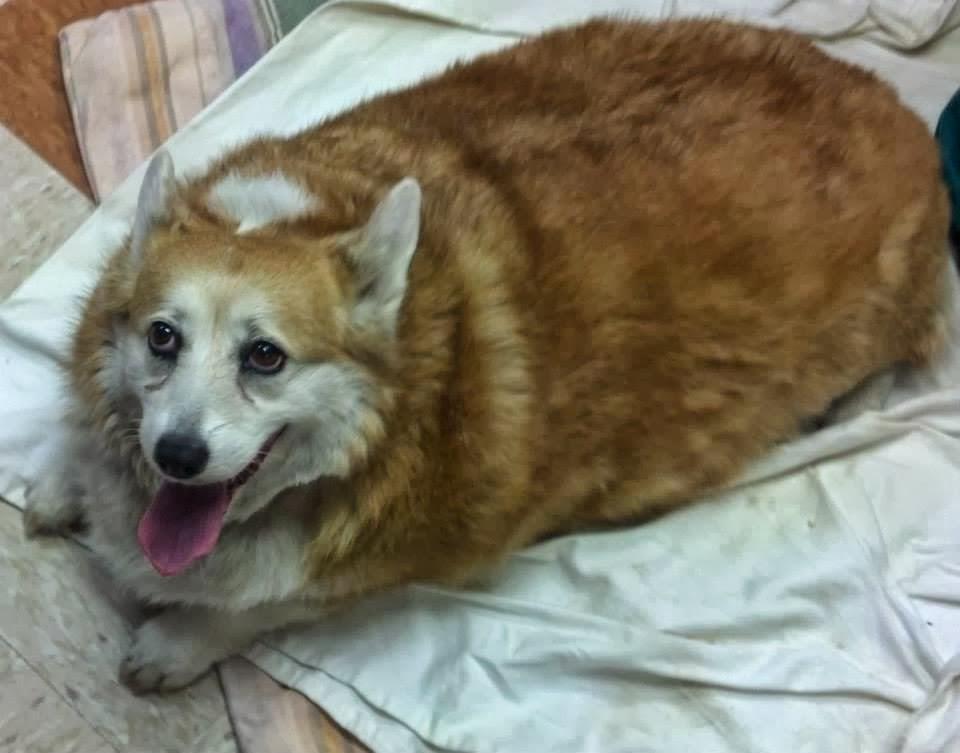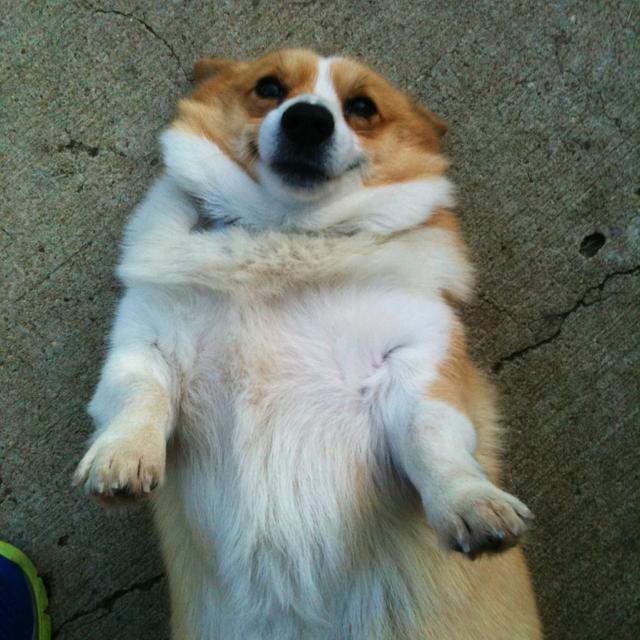The first image is the image on the left, the second image is the image on the right. Considering the images on both sides, is "A dog in the image on the left is lying down with its tongue hanging out." valid? Answer yes or no. Yes. The first image is the image on the left, the second image is the image on the right. Assess this claim about the two images: "The corgi's are outside laying in or near the green grass". Correct or not? Answer yes or no. No. 